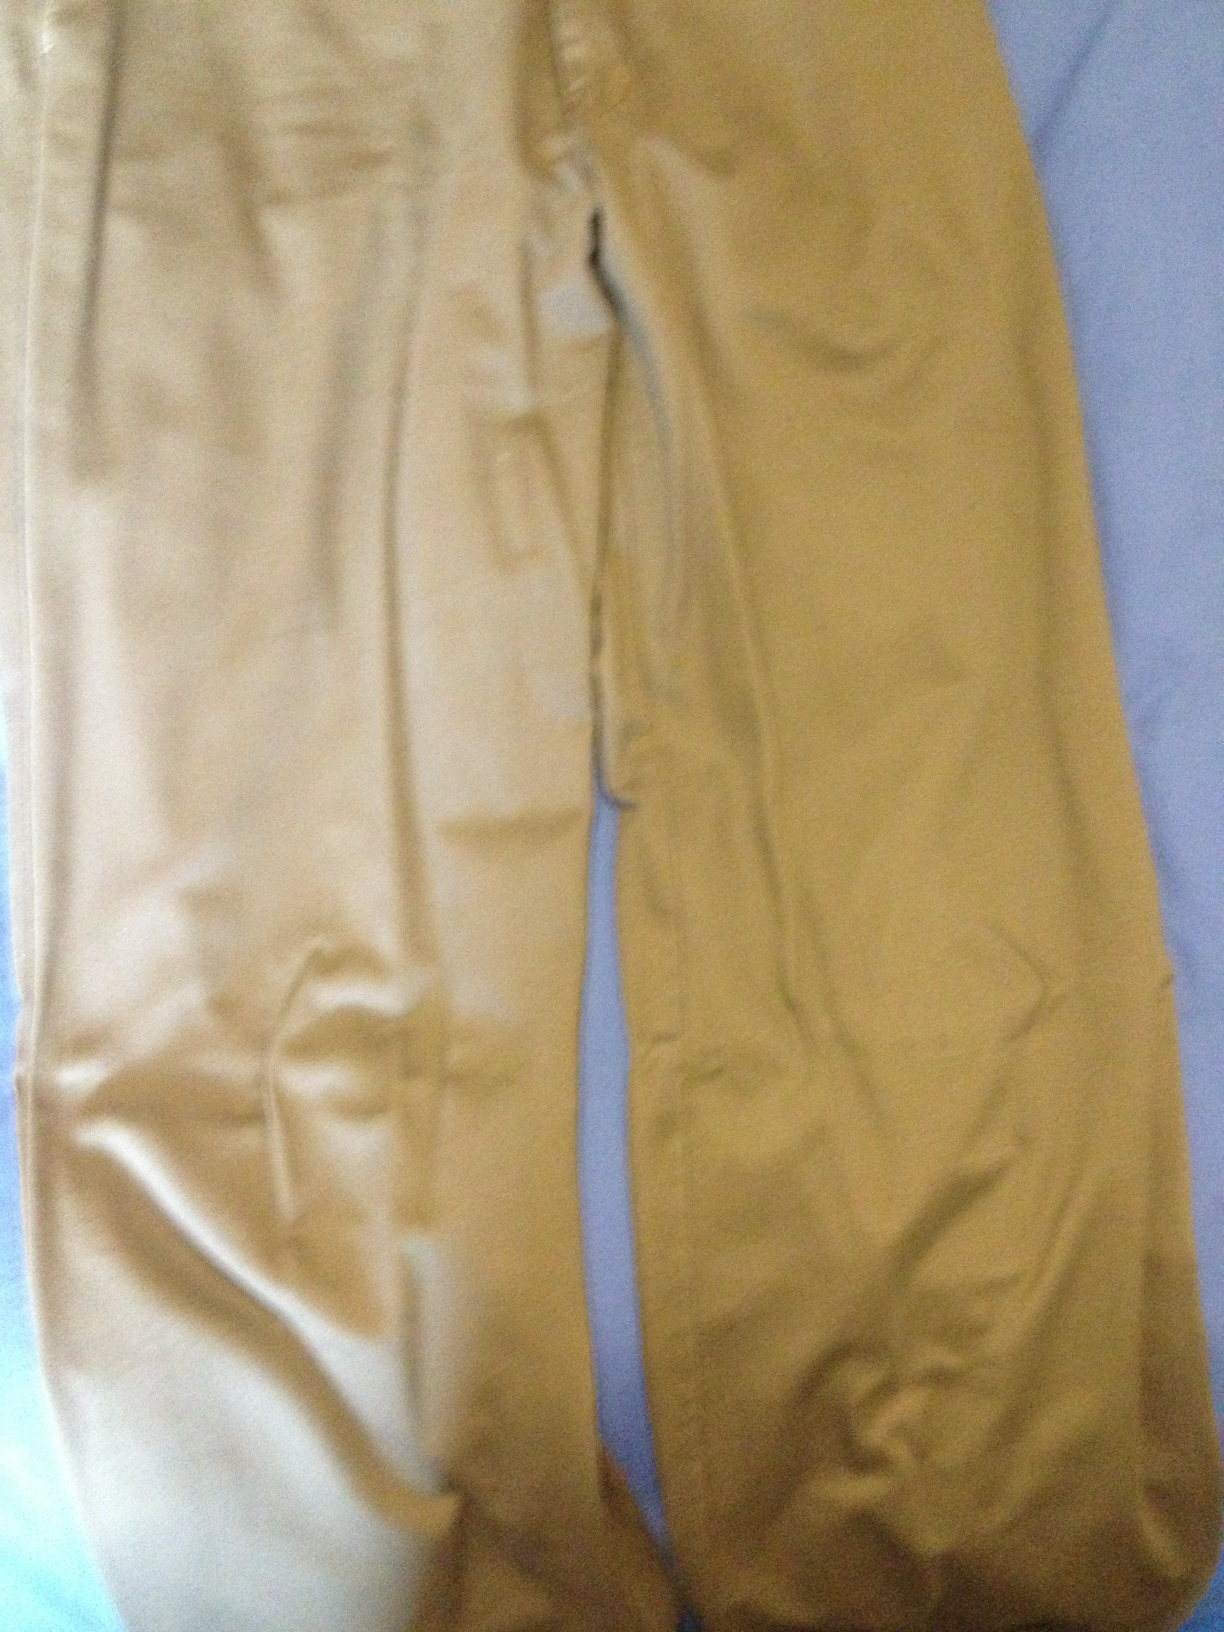Could you tell me what color these trousers are, please. Certainly! The trousers in the image have a warm khaki hue, a color that is versatile and often used in casual and work attire for its neutral and earthy tone. 